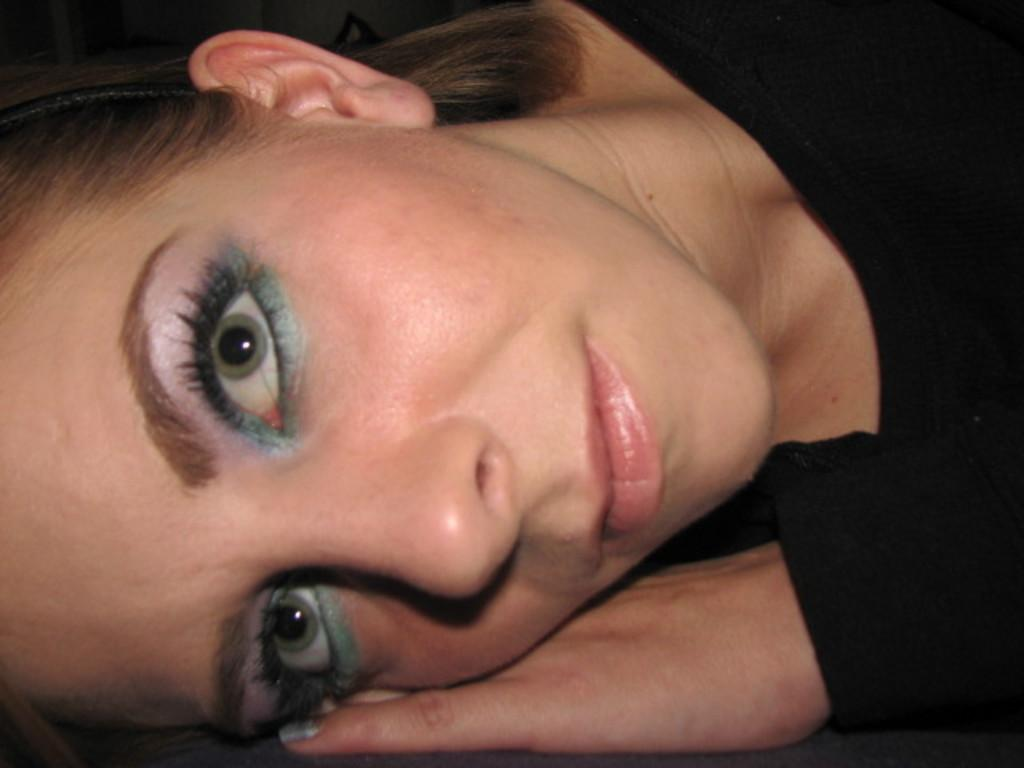What is the main subject of the image? There is a woman in the image. What is the woman wearing in the image? The woman is wearing a black t-shirt. What shape is the woman coughing in the image? There is no indication in the image that the woman is coughing or that any specific shape is associated with her actions. 